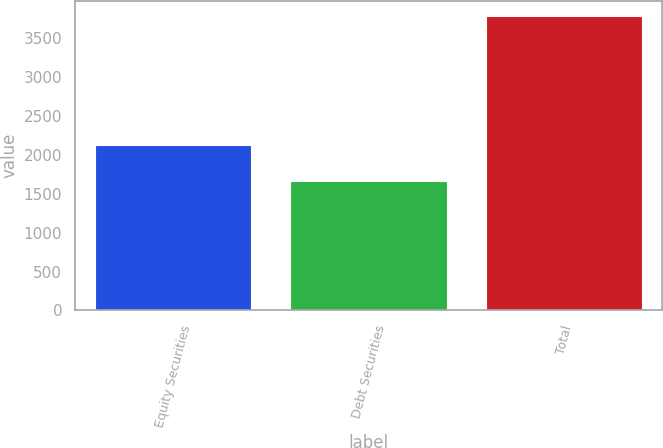<chart> <loc_0><loc_0><loc_500><loc_500><bar_chart><fcel>Equity Securities<fcel>Debt Securities<fcel>Total<nl><fcel>2129<fcel>1659<fcel>3788<nl></chart> 